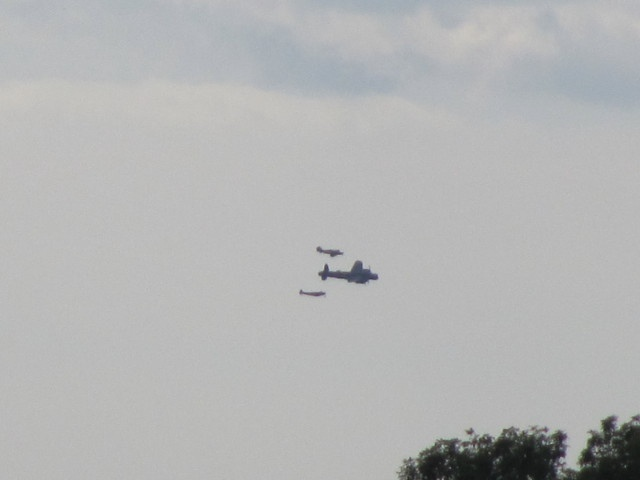Describe the objects in this image and their specific colors. I can see airplane in darkgray, gray, and darkblue tones, airplane in darkgray and gray tones, and airplane in darkgray and gray tones in this image. 